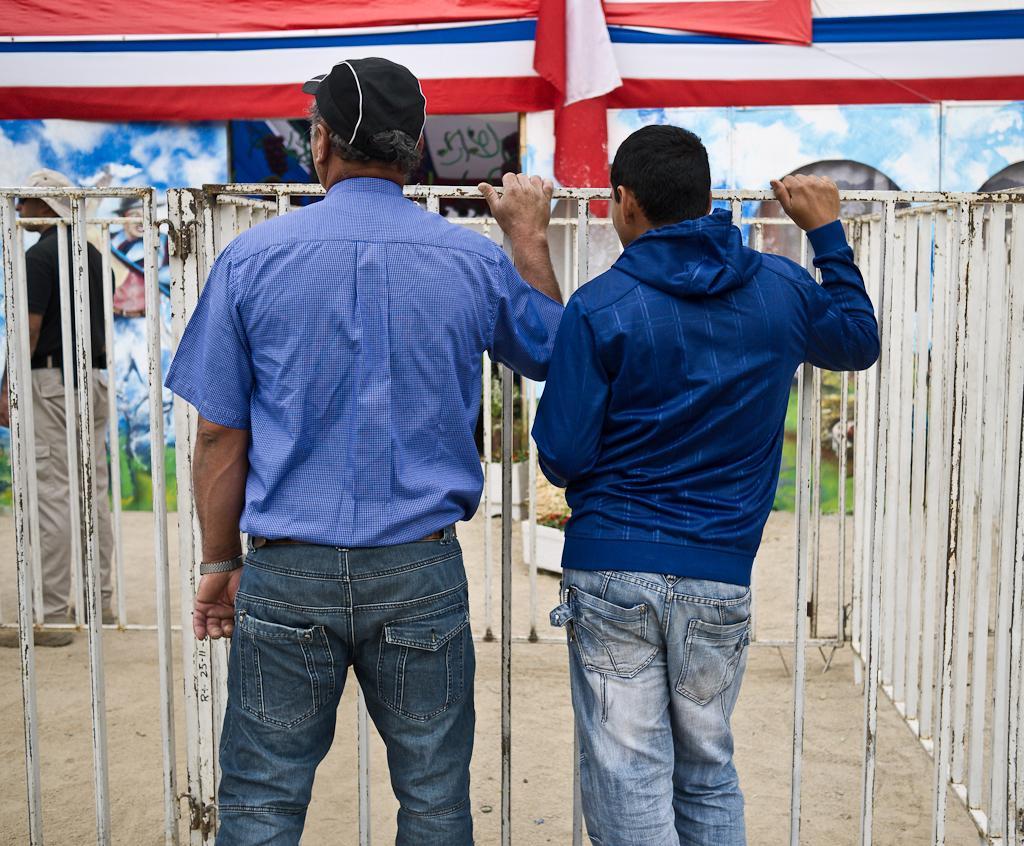Describe this image in one or two sentences. In this image we can see people standing and there is a grille. In the background there are clothes and sky. 